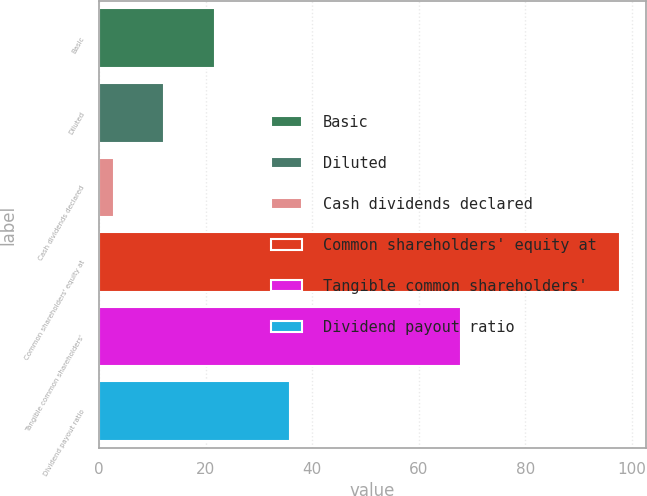Convert chart to OTSL. <chart><loc_0><loc_0><loc_500><loc_500><bar_chart><fcel>Basic<fcel>Diluted<fcel>Cash dividends declared<fcel>Common shareholders' equity at<fcel>Tangible common shareholders'<fcel>Dividend payout ratio<nl><fcel>21.76<fcel>12.28<fcel>2.8<fcel>97.64<fcel>67.85<fcel>35.81<nl></chart> 